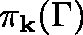Convert formula to latex. <formula><loc_0><loc_0><loc_500><loc_500>\pi _ { k } ( \Gamma )</formula> 